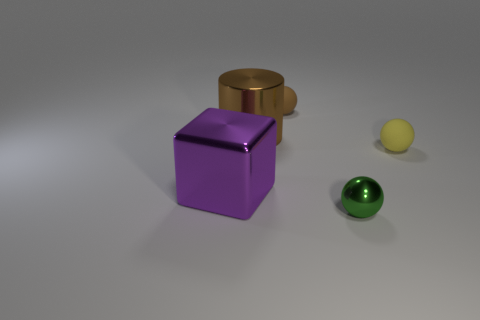Subtract all rubber spheres. How many spheres are left? 1 Subtract all yellow balls. How many balls are left? 2 Subtract all gray blocks. How many yellow balls are left? 1 Subtract all tiny objects. Subtract all tiny green metal spheres. How many objects are left? 1 Add 5 large purple objects. How many large purple objects are left? 6 Add 3 big gray cylinders. How many big gray cylinders exist? 3 Add 3 cylinders. How many objects exist? 8 Subtract 0 purple spheres. How many objects are left? 5 Subtract all cubes. How many objects are left? 4 Subtract 1 spheres. How many spheres are left? 2 